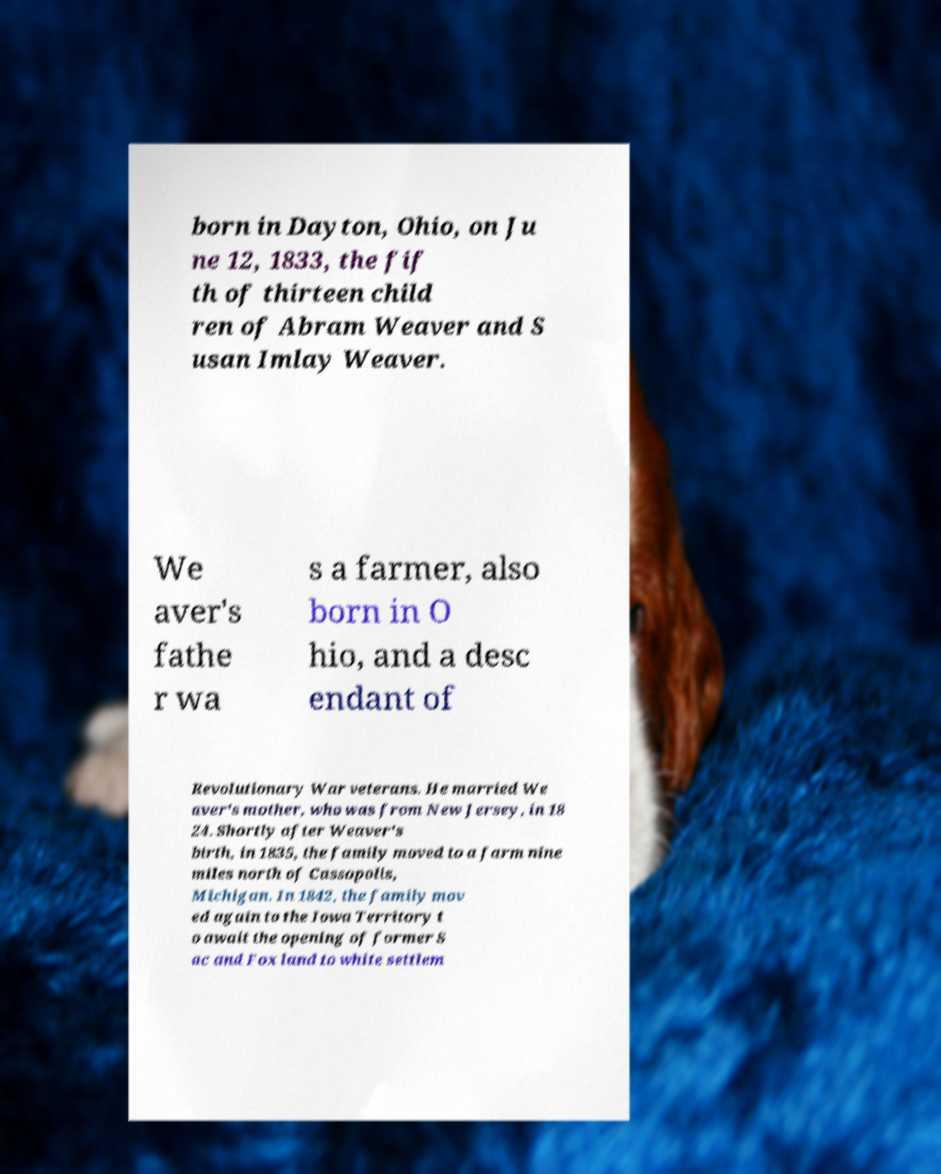Please identify and transcribe the text found in this image. born in Dayton, Ohio, on Ju ne 12, 1833, the fif th of thirteen child ren of Abram Weaver and S usan Imlay Weaver. We aver's fathe r wa s a farmer, also born in O hio, and a desc endant of Revolutionary War veterans. He married We aver's mother, who was from New Jersey, in 18 24. Shortly after Weaver's birth, in 1835, the family moved to a farm nine miles north of Cassopolis, Michigan. In 1842, the family mov ed again to the Iowa Territory t o await the opening of former S ac and Fox land to white settlem 